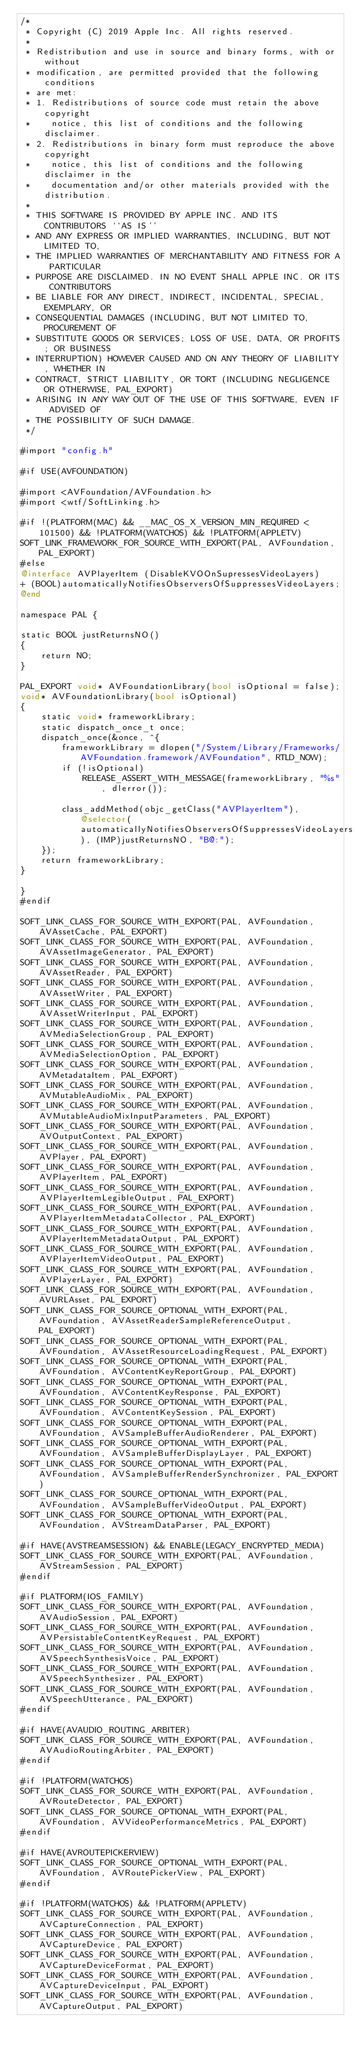<code> <loc_0><loc_0><loc_500><loc_500><_ObjectiveC_>/*
 * Copyright (C) 2019 Apple Inc. All rights reserved.
 *
 * Redistribution and use in source and binary forms, with or without
 * modification, are permitted provided that the following conditions
 * are met:
 * 1. Redistributions of source code must retain the above copyright
 *    notice, this list of conditions and the following disclaimer.
 * 2. Redistributions in binary form must reproduce the above copyright
 *    notice, this list of conditions and the following disclaimer in the
 *    documentation and/or other materials provided with the distribution.
 *
 * THIS SOFTWARE IS PROVIDED BY APPLE INC. AND ITS CONTRIBUTORS ``AS IS''
 * AND ANY EXPRESS OR IMPLIED WARRANTIES, INCLUDING, BUT NOT LIMITED TO,
 * THE IMPLIED WARRANTIES OF MERCHANTABILITY AND FITNESS FOR A PARTICULAR
 * PURPOSE ARE DISCLAIMED. IN NO EVENT SHALL APPLE INC. OR ITS CONTRIBUTORS
 * BE LIABLE FOR ANY DIRECT, INDIRECT, INCIDENTAL, SPECIAL, EXEMPLARY, OR
 * CONSEQUENTIAL DAMAGES (INCLUDING, BUT NOT LIMITED TO, PROCUREMENT OF
 * SUBSTITUTE GOODS OR SERVICES; LOSS OF USE, DATA, OR PROFITS; OR BUSINESS
 * INTERRUPTION) HOWEVER CAUSED AND ON ANY THEORY OF LIABILITY, WHETHER IN
 * CONTRACT, STRICT LIABILITY, OR TORT (INCLUDING NEGLIGENCE OR OTHERWISE, PAL_EXPORT)
 * ARISING IN ANY WAY OUT OF THE USE OF THIS SOFTWARE, EVEN IF ADVISED OF
 * THE POSSIBILITY OF SUCH DAMAGE.
 */

#import "config.h"

#if USE(AVFOUNDATION)

#import <AVFoundation/AVFoundation.h>
#import <wtf/SoftLinking.h>

#if !(PLATFORM(MAC) && __MAC_OS_X_VERSION_MIN_REQUIRED < 101500) && !PLATFORM(WATCHOS) && !PLATFORM(APPLETV)
SOFT_LINK_FRAMEWORK_FOR_SOURCE_WITH_EXPORT(PAL, AVFoundation, PAL_EXPORT)
#else
@interface AVPlayerItem (DisableKVOOnSupressesVideoLayers)
+ (BOOL)automaticallyNotifiesObserversOfSuppressesVideoLayers;
@end

namespace PAL {

static BOOL justReturnsNO()
{
    return NO;
}

PAL_EXPORT void* AVFoundationLibrary(bool isOptional = false);
void* AVFoundationLibrary(bool isOptional)
{
    static void* frameworkLibrary;
    static dispatch_once_t once;
    dispatch_once(&once, ^{
        frameworkLibrary = dlopen("/System/Library/Frameworks/AVFoundation.framework/AVFoundation", RTLD_NOW);
        if (!isOptional)
            RELEASE_ASSERT_WITH_MESSAGE(frameworkLibrary, "%s", dlerror());

        class_addMethod(objc_getClass("AVPlayerItem"), @selector(automaticallyNotifiesObserversOfSuppressesVideoLayers), (IMP)justReturnsNO, "B@:");
    });
    return frameworkLibrary;
}

}
#endif

SOFT_LINK_CLASS_FOR_SOURCE_WITH_EXPORT(PAL, AVFoundation, AVAssetCache, PAL_EXPORT)
SOFT_LINK_CLASS_FOR_SOURCE_WITH_EXPORT(PAL, AVFoundation, AVAssetImageGenerator, PAL_EXPORT)
SOFT_LINK_CLASS_FOR_SOURCE_WITH_EXPORT(PAL, AVFoundation, AVAssetReader, PAL_EXPORT)
SOFT_LINK_CLASS_FOR_SOURCE_WITH_EXPORT(PAL, AVFoundation, AVAssetWriter, PAL_EXPORT)
SOFT_LINK_CLASS_FOR_SOURCE_WITH_EXPORT(PAL, AVFoundation, AVAssetWriterInput, PAL_EXPORT)
SOFT_LINK_CLASS_FOR_SOURCE_WITH_EXPORT(PAL, AVFoundation, AVMediaSelectionGroup, PAL_EXPORT)
SOFT_LINK_CLASS_FOR_SOURCE_WITH_EXPORT(PAL, AVFoundation, AVMediaSelectionOption, PAL_EXPORT)
SOFT_LINK_CLASS_FOR_SOURCE_WITH_EXPORT(PAL, AVFoundation, AVMetadataItem, PAL_EXPORT)
SOFT_LINK_CLASS_FOR_SOURCE_WITH_EXPORT(PAL, AVFoundation, AVMutableAudioMix, PAL_EXPORT)
SOFT_LINK_CLASS_FOR_SOURCE_WITH_EXPORT(PAL, AVFoundation, AVMutableAudioMixInputParameters, PAL_EXPORT)
SOFT_LINK_CLASS_FOR_SOURCE_WITH_EXPORT(PAL, AVFoundation, AVOutputContext, PAL_EXPORT)
SOFT_LINK_CLASS_FOR_SOURCE_WITH_EXPORT(PAL, AVFoundation, AVPlayer, PAL_EXPORT)
SOFT_LINK_CLASS_FOR_SOURCE_WITH_EXPORT(PAL, AVFoundation, AVPlayerItem, PAL_EXPORT)
SOFT_LINK_CLASS_FOR_SOURCE_WITH_EXPORT(PAL, AVFoundation, AVPlayerItemLegibleOutput, PAL_EXPORT)
SOFT_LINK_CLASS_FOR_SOURCE_WITH_EXPORT(PAL, AVFoundation, AVPlayerItemMetadataCollector, PAL_EXPORT)
SOFT_LINK_CLASS_FOR_SOURCE_WITH_EXPORT(PAL, AVFoundation, AVPlayerItemMetadataOutput, PAL_EXPORT)
SOFT_LINK_CLASS_FOR_SOURCE_WITH_EXPORT(PAL, AVFoundation, AVPlayerItemVideoOutput, PAL_EXPORT)
SOFT_LINK_CLASS_FOR_SOURCE_WITH_EXPORT(PAL, AVFoundation, AVPlayerLayer, PAL_EXPORT)
SOFT_LINK_CLASS_FOR_SOURCE_WITH_EXPORT(PAL, AVFoundation, AVURLAsset, PAL_EXPORT)
SOFT_LINK_CLASS_FOR_SOURCE_OPTIONAL_WITH_EXPORT(PAL, AVFoundation, AVAssetReaderSampleReferenceOutput, PAL_EXPORT)
SOFT_LINK_CLASS_FOR_SOURCE_OPTIONAL_WITH_EXPORT(PAL, AVFoundation, AVAssetResourceLoadingRequest, PAL_EXPORT)
SOFT_LINK_CLASS_FOR_SOURCE_OPTIONAL_WITH_EXPORT(PAL, AVFoundation, AVContentKeyReportGroup, PAL_EXPORT)
SOFT_LINK_CLASS_FOR_SOURCE_OPTIONAL_WITH_EXPORT(PAL, AVFoundation, AVContentKeyResponse, PAL_EXPORT)
SOFT_LINK_CLASS_FOR_SOURCE_OPTIONAL_WITH_EXPORT(PAL, AVFoundation, AVContentKeySession, PAL_EXPORT)
SOFT_LINK_CLASS_FOR_SOURCE_OPTIONAL_WITH_EXPORT(PAL, AVFoundation, AVSampleBufferAudioRenderer, PAL_EXPORT)
SOFT_LINK_CLASS_FOR_SOURCE_OPTIONAL_WITH_EXPORT(PAL, AVFoundation, AVSampleBufferDisplayLayer, PAL_EXPORT)
SOFT_LINK_CLASS_FOR_SOURCE_OPTIONAL_WITH_EXPORT(PAL, AVFoundation, AVSampleBufferRenderSynchronizer, PAL_EXPORT)
SOFT_LINK_CLASS_FOR_SOURCE_OPTIONAL_WITH_EXPORT(PAL, AVFoundation, AVSampleBufferVideoOutput, PAL_EXPORT)
SOFT_LINK_CLASS_FOR_SOURCE_OPTIONAL_WITH_EXPORT(PAL, AVFoundation, AVStreamDataParser, PAL_EXPORT)

#if HAVE(AVSTREAMSESSION) && ENABLE(LEGACY_ENCRYPTED_MEDIA)
SOFT_LINK_CLASS_FOR_SOURCE_WITH_EXPORT(PAL, AVFoundation, AVStreamSession, PAL_EXPORT)
#endif

#if PLATFORM(IOS_FAMILY)
SOFT_LINK_CLASS_FOR_SOURCE_WITH_EXPORT(PAL, AVFoundation, AVAudioSession, PAL_EXPORT)
SOFT_LINK_CLASS_FOR_SOURCE_WITH_EXPORT(PAL, AVFoundation, AVPersistableContentKeyRequest, PAL_EXPORT)
SOFT_LINK_CLASS_FOR_SOURCE_WITH_EXPORT(PAL, AVFoundation, AVSpeechSynthesisVoice, PAL_EXPORT)
SOFT_LINK_CLASS_FOR_SOURCE_WITH_EXPORT(PAL, AVFoundation, AVSpeechSynthesizer, PAL_EXPORT)
SOFT_LINK_CLASS_FOR_SOURCE_WITH_EXPORT(PAL, AVFoundation, AVSpeechUtterance, PAL_EXPORT)
#endif

#if HAVE(AVAUDIO_ROUTING_ARBITER)
SOFT_LINK_CLASS_FOR_SOURCE_WITH_EXPORT(PAL, AVFoundation, AVAudioRoutingArbiter, PAL_EXPORT)
#endif

#if !PLATFORM(WATCHOS)
SOFT_LINK_CLASS_FOR_SOURCE_WITH_EXPORT(PAL, AVFoundation, AVRouteDetector, PAL_EXPORT)
SOFT_LINK_CLASS_FOR_SOURCE_OPTIONAL_WITH_EXPORT(PAL, AVFoundation, AVVideoPerformanceMetrics, PAL_EXPORT)
#endif

#if HAVE(AVROUTEPICKERVIEW)
SOFT_LINK_CLASS_FOR_SOURCE_OPTIONAL_WITH_EXPORT(PAL, AVFoundation, AVRoutePickerView, PAL_EXPORT)
#endif

#if !PLATFORM(WATCHOS) && !PLATFORM(APPLETV)
SOFT_LINK_CLASS_FOR_SOURCE_WITH_EXPORT(PAL, AVFoundation, AVCaptureConnection, PAL_EXPORT)
SOFT_LINK_CLASS_FOR_SOURCE_WITH_EXPORT(PAL, AVFoundation, AVCaptureDevice, PAL_EXPORT)
SOFT_LINK_CLASS_FOR_SOURCE_WITH_EXPORT(PAL, AVFoundation, AVCaptureDeviceFormat, PAL_EXPORT)
SOFT_LINK_CLASS_FOR_SOURCE_WITH_EXPORT(PAL, AVFoundation, AVCaptureDeviceInput, PAL_EXPORT)
SOFT_LINK_CLASS_FOR_SOURCE_WITH_EXPORT(PAL, AVFoundation, AVCaptureOutput, PAL_EXPORT)</code> 